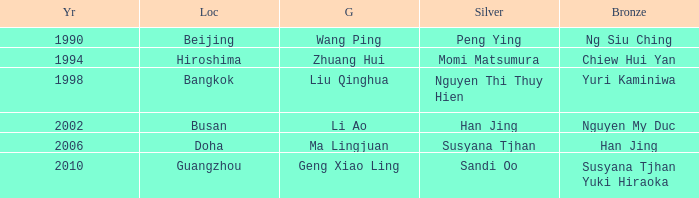What Silver has a Golf of Li AO? Han Jing. 